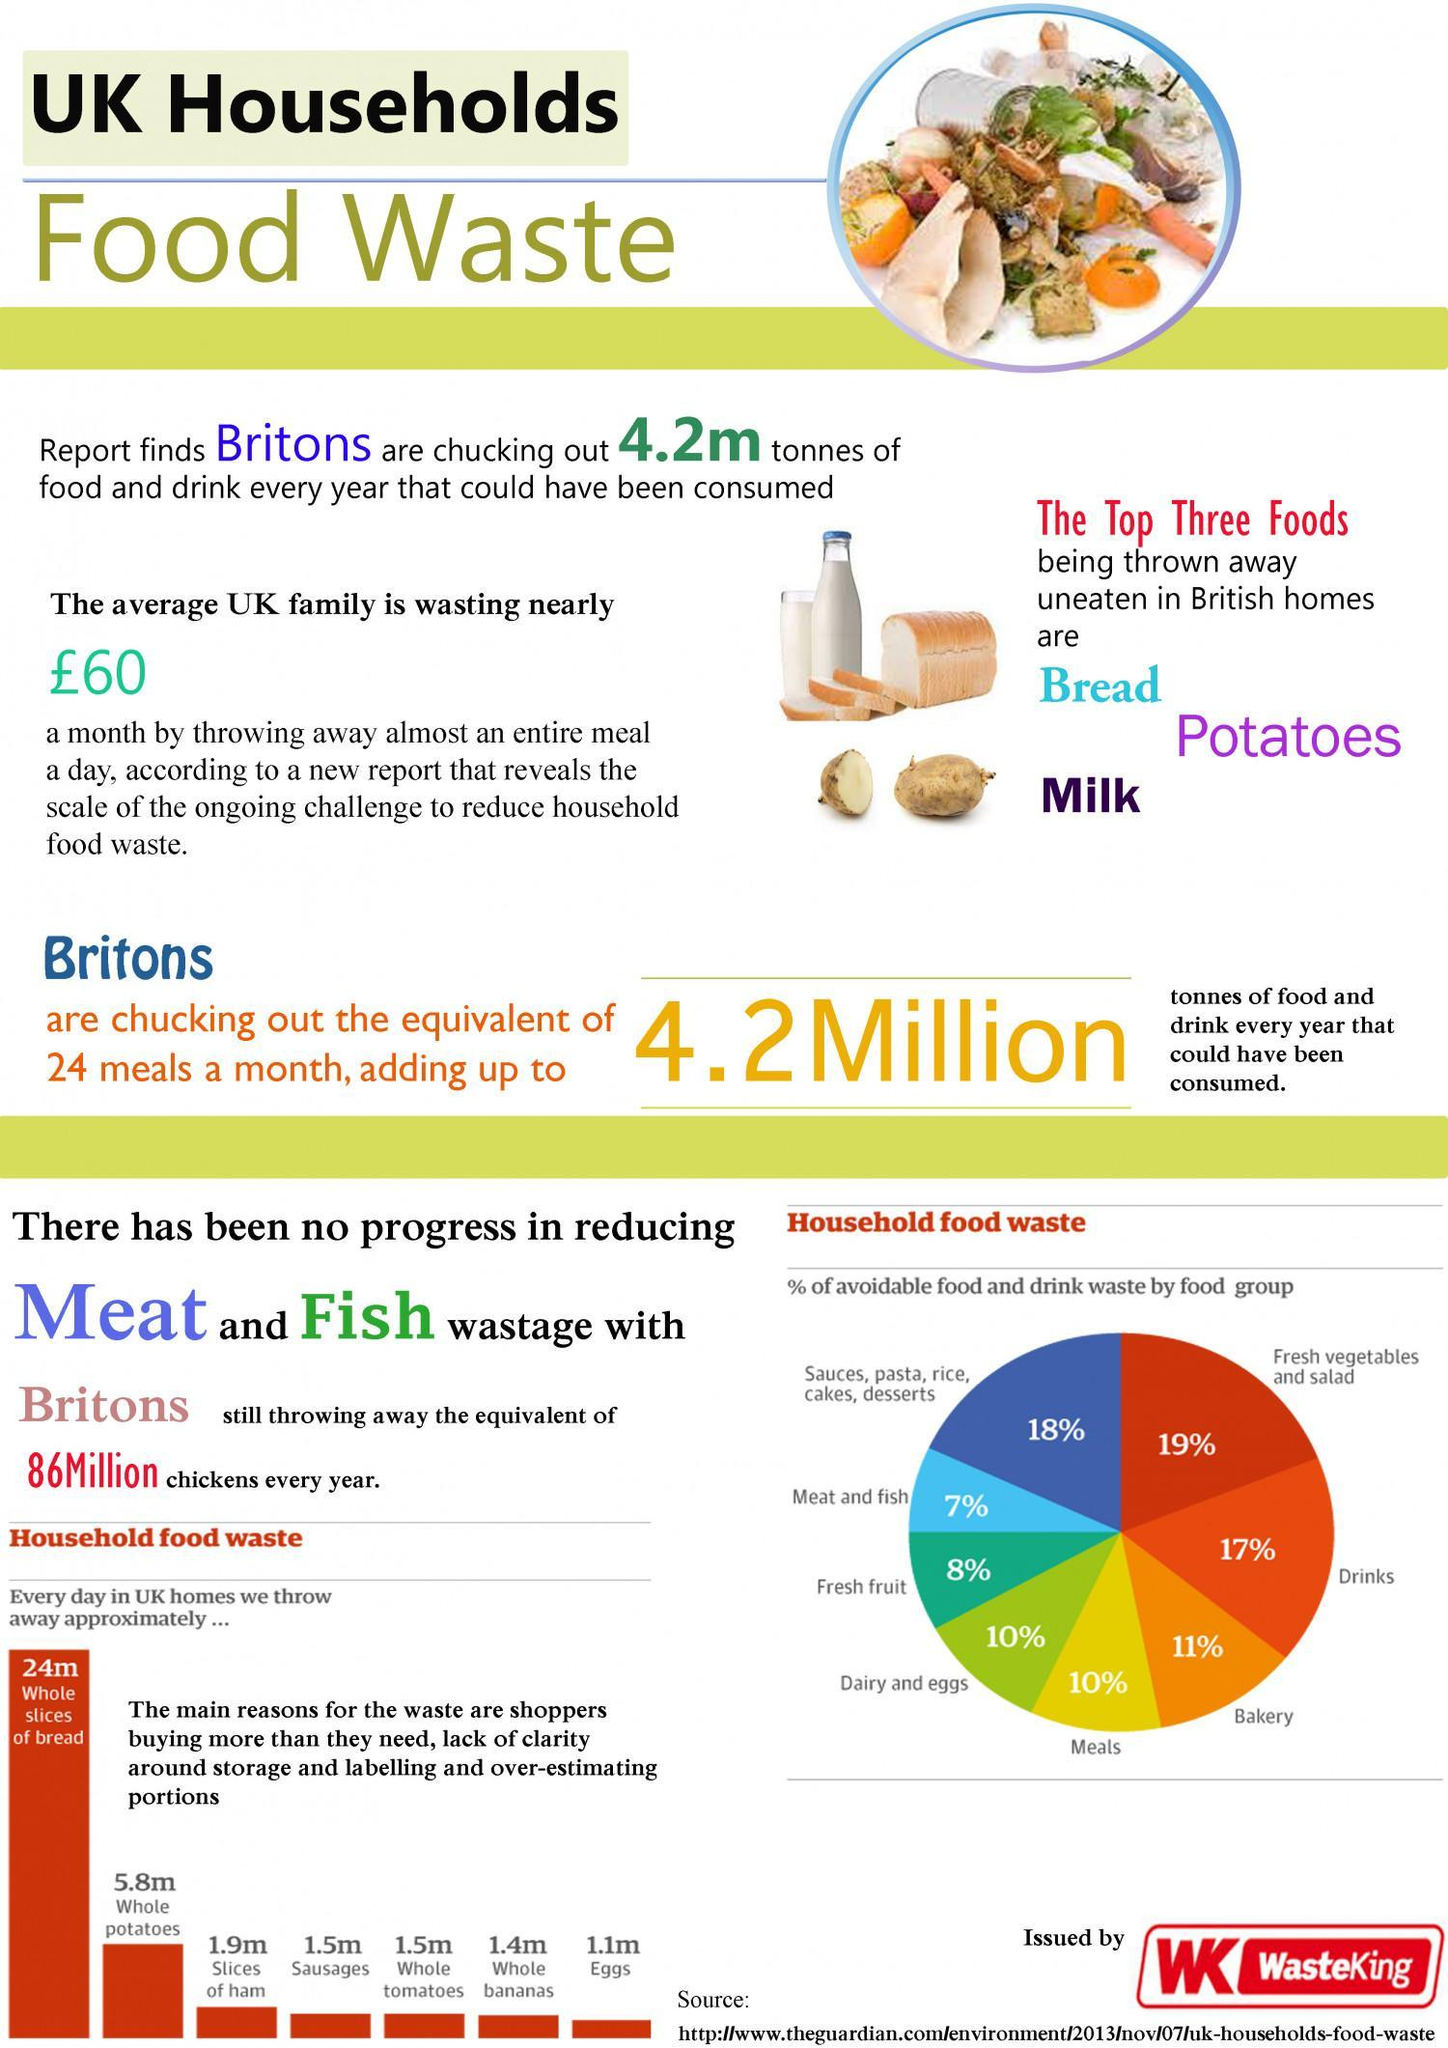Which color is given to show the waste percentage of Meals- yellow, white, red, black?
Answer the question with a short phrase. yellow How many house hold food items have waste quantity equal to 1.5m? 2 Which are the major food items which are being wasted in UK houses? Bread, Potatoes, Milk How many house hold food items have waste quantity less than 1.5m? 2 Which is the third most house hold food item being wasted in UK? slices of ham Which color is given to show the waste percentage of Bakery- yellow, white, orange, black? orange Which is the second most house hold food item being wasted in UK? Whole Potatoes 